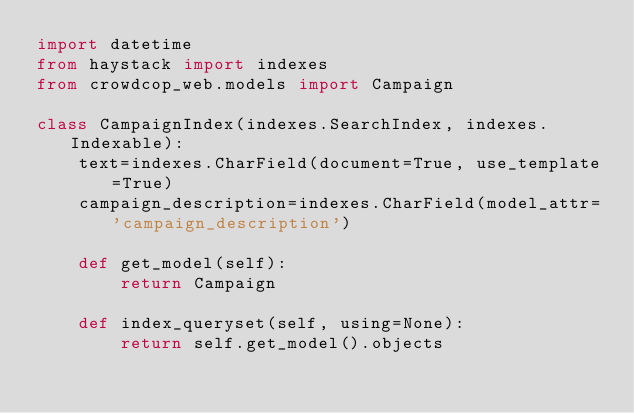<code> <loc_0><loc_0><loc_500><loc_500><_Python_>import datetime
from haystack import indexes
from crowdcop_web.models import Campaign

class CampaignIndex(indexes.SearchIndex, indexes.Indexable):
	text=indexes.CharField(document=True, use_template=True)
	campaign_description=indexes.CharField(model_attr='campaign_description')

	def get_model(self):
		return Campaign

	def index_queryset(self, using=None):
		return self.get_model().objects
</code> 